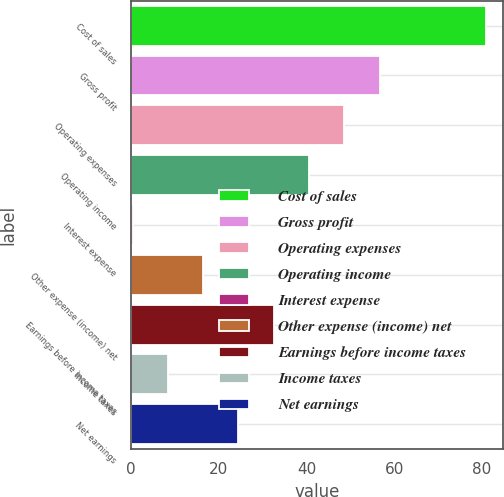Convert chart to OTSL. <chart><loc_0><loc_0><loc_500><loc_500><bar_chart><fcel>Cost of sales<fcel>Gross profit<fcel>Operating expenses<fcel>Operating income<fcel>Interest expense<fcel>Other expense (income) net<fcel>Earnings before income taxes<fcel>Income taxes<fcel>Net earnings<nl><fcel>80.9<fcel>56.72<fcel>48.66<fcel>40.6<fcel>0.3<fcel>16.42<fcel>32.54<fcel>8.36<fcel>24.48<nl></chart> 